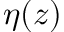<formula> <loc_0><loc_0><loc_500><loc_500>\eta ( z )</formula> 